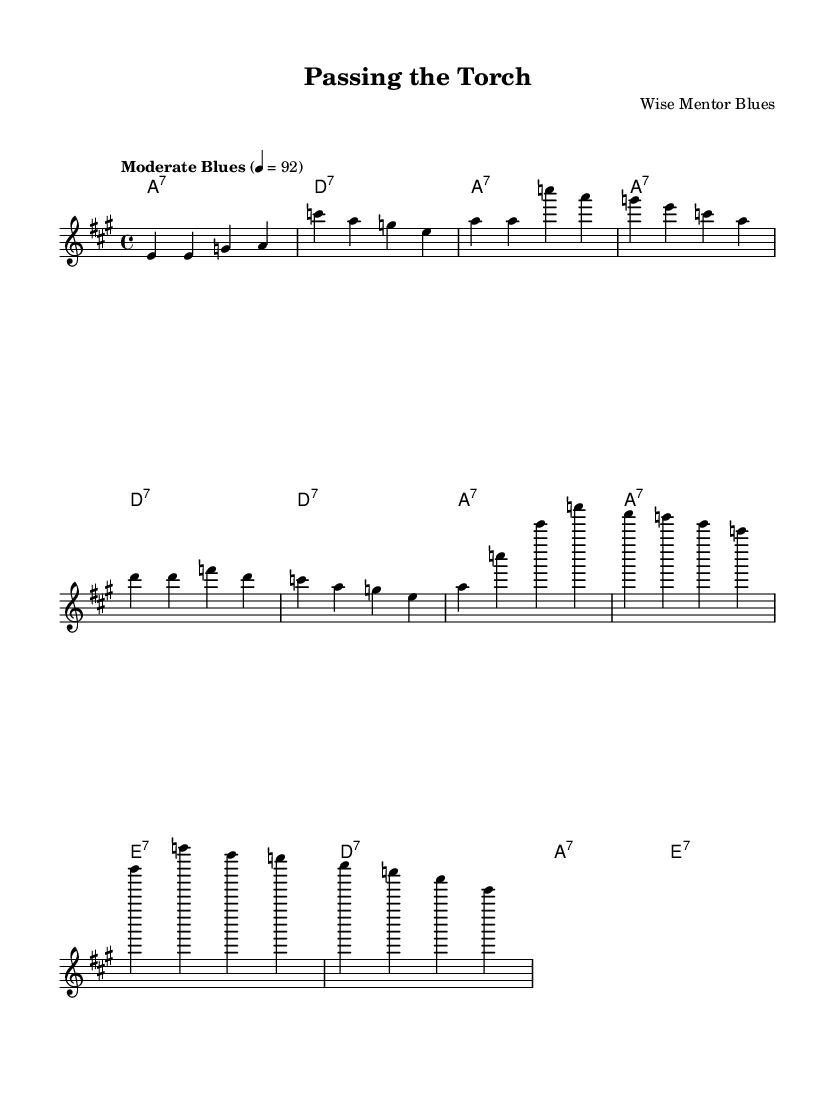What is the key signature of this music? The key signature is indicated at the beginning of the sheet music with accidentals. In this case, it shows two sharps, which corresponds to the key of A major.
Answer: A major What is the time signature of this piece? The time signature is located right after the key signature, and it indicates the number of beats in a measure. Here, the time signature is 4/4, meaning there are 4 beats in each measure.
Answer: 4/4 What is the tempo marking for this music? The tempo marking is typically found above the staff, indicating the speed of the music. In this sheet, it states "Moderate Blues" at 92 beats per minute.
Answer: Moderate Blues 92 How many measures are in the chorus? The chorus can be identified by counting the individual measures it contains. In this case, there are 4 measures in the chorus section of the sheet music.
Answer: 4 What type of chords are used in the harmonies section? The chord mode section indicates the types of chords used. Here, they are all dominant seventh chords, shown as a "7" after each root note (e.g., a1:7).
Answer: Dominant seventh chords What is the form of this blues piece? The structure of a typical blues song often follows a pattern of verses and chorus. In this sheet music, the form follows a verse-chorus format, which alternates between verses and the chorus.
Answer: Verse-Chorus 